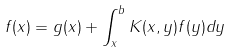Convert formula to latex. <formula><loc_0><loc_0><loc_500><loc_500>f ( x ) = g ( x ) + \int _ { x } ^ { b } K ( x , y ) f ( y ) d y</formula> 